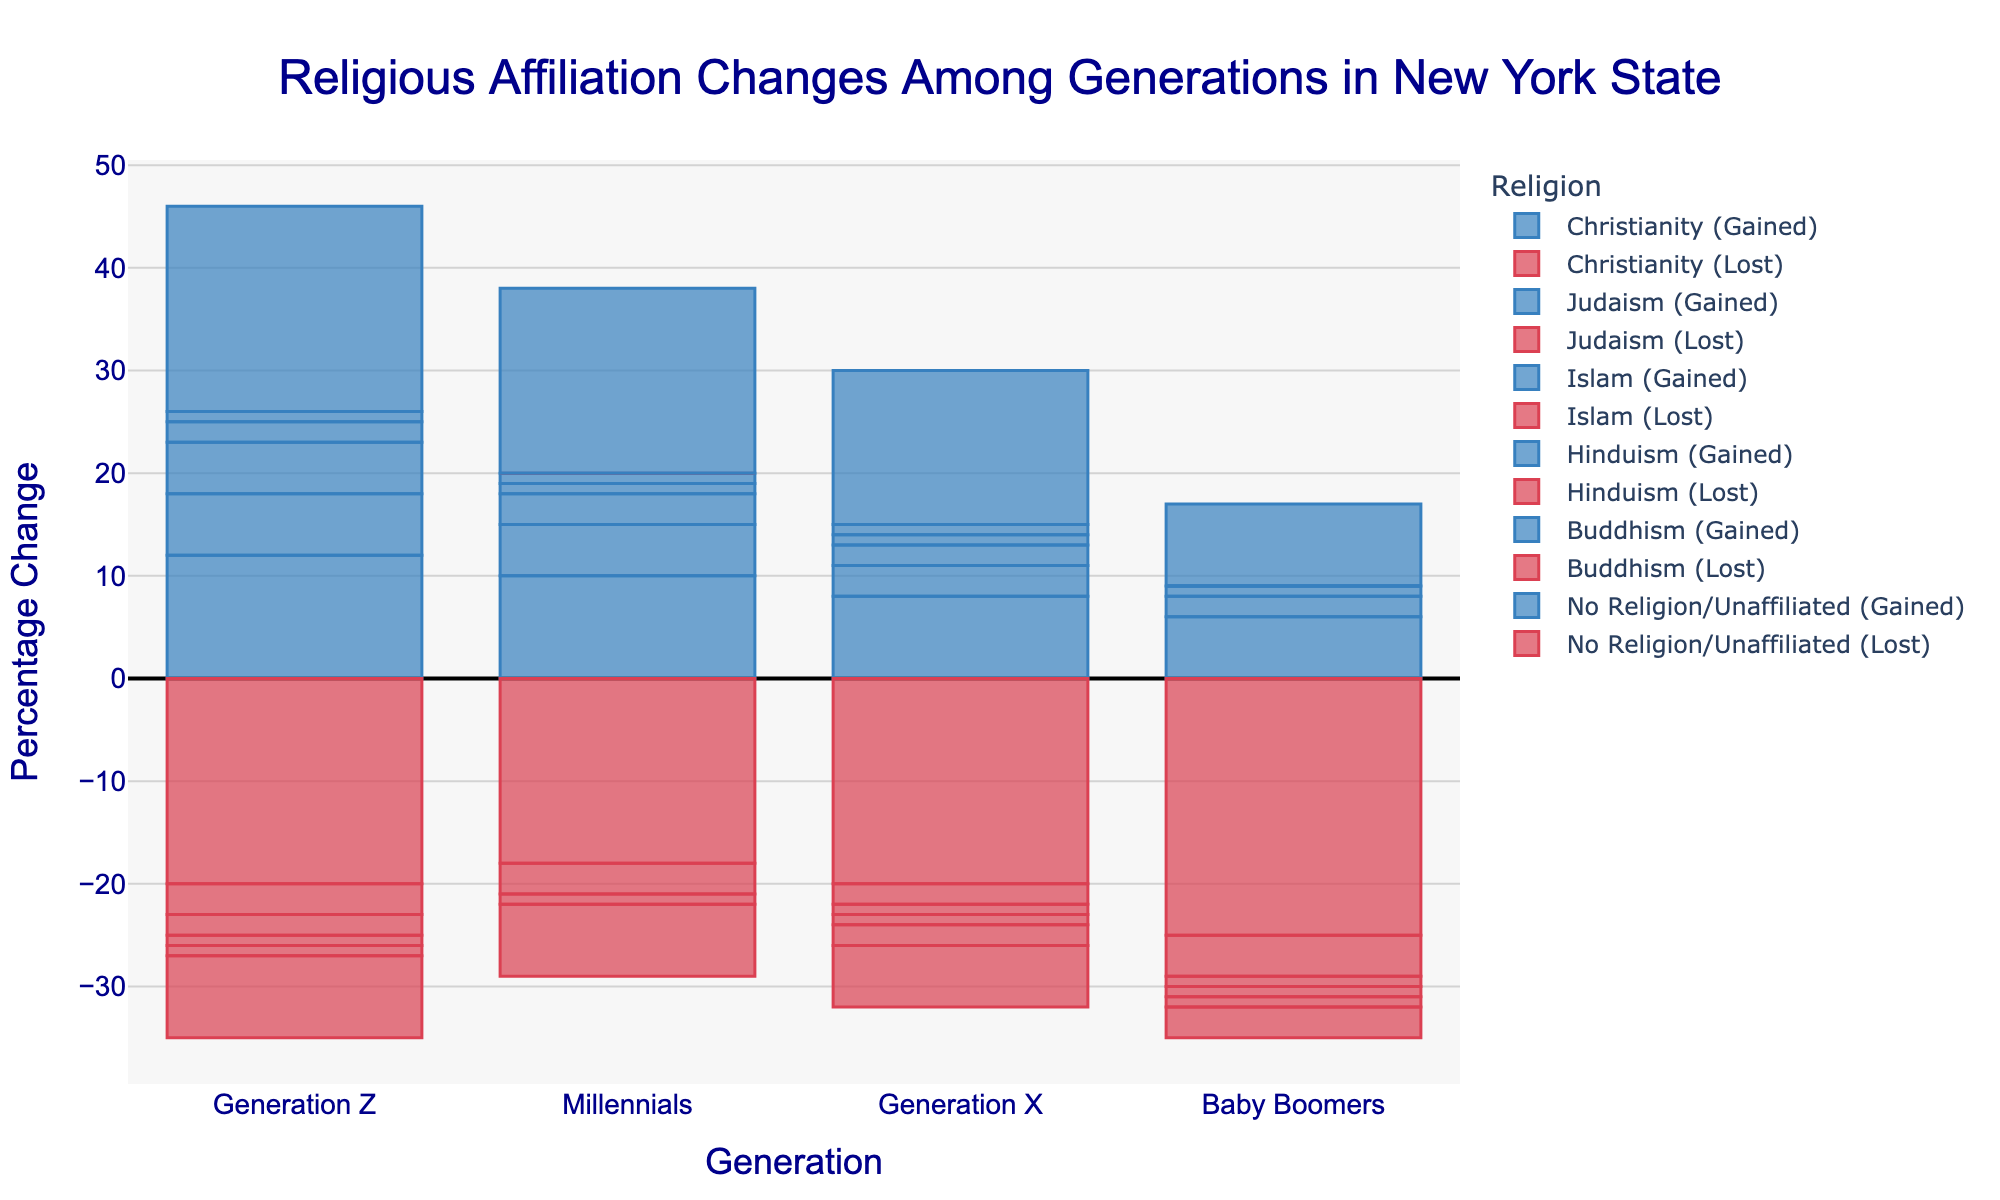Which generation saw the highest net gain in the category of "No Religion/Unaffiliated"? Look at the bars representing net changes for "No Religion/Unaffiliated" across all generations. The bar with the highest value is the generation with the highest net gain.
Answer: Generation Z Which religious affiliation experienced the largest net loss among Baby Boomers? Observe the net change values for all religions among Baby Boomers and identify the smallest (most negative) value.
Answer: Christianity Compare the net changes in Christianity between Generation Z and Millennials. Which generation saw a larger net loss? Compare the net change bars for Christianity between Generation Z and Millennials. The generation with the more negative value saw a larger net loss.
Answer: Both Generation Z and Millennials saw a net loss of -8 What is the total number of people who either gained or lost affiliation with Hinduism across all generations? Add up the "Gained" and "Lost" values for Hinduism across Generation Z, Millennials, Generation X, and Baby Boomers. (2+1+1+1) + (1+0+1+1) + (0+0) = 7
Answer: 7 Which generation has the smallest disparity between gained and lost affiliations for Judaism? Calculate the absolute differences between "Gained" and "Lost" values for Judaism across all generations. The generation with the smallest absolute difference has the smallest disparity.
Answer: Generation Z What color represents the bars for gained affiliations in the figure? Identify the common color used for all "Gained" bars by observing the visual attributes.
Answer: Blue What is the overall trend in net change for Christianity across generations? Examine the net change bars for Christianity across all generations and describe the general pattern or trend.
Answer: Decreasing trend Which generation has the highest net gain in Islam? Look at net changes in Islam across all generations and identify the highest positive value.
Answer: Generation Z If you sum the net changes for "No Religion/Unaffiliated" across all generations, what is the total net change? Sum the net change values for "No Religion/Unaffiliated" across Generation Z (12), Millennials (11), Generation X (9), and Baby Boomers (5) to find the total net change.
Answer: 37 